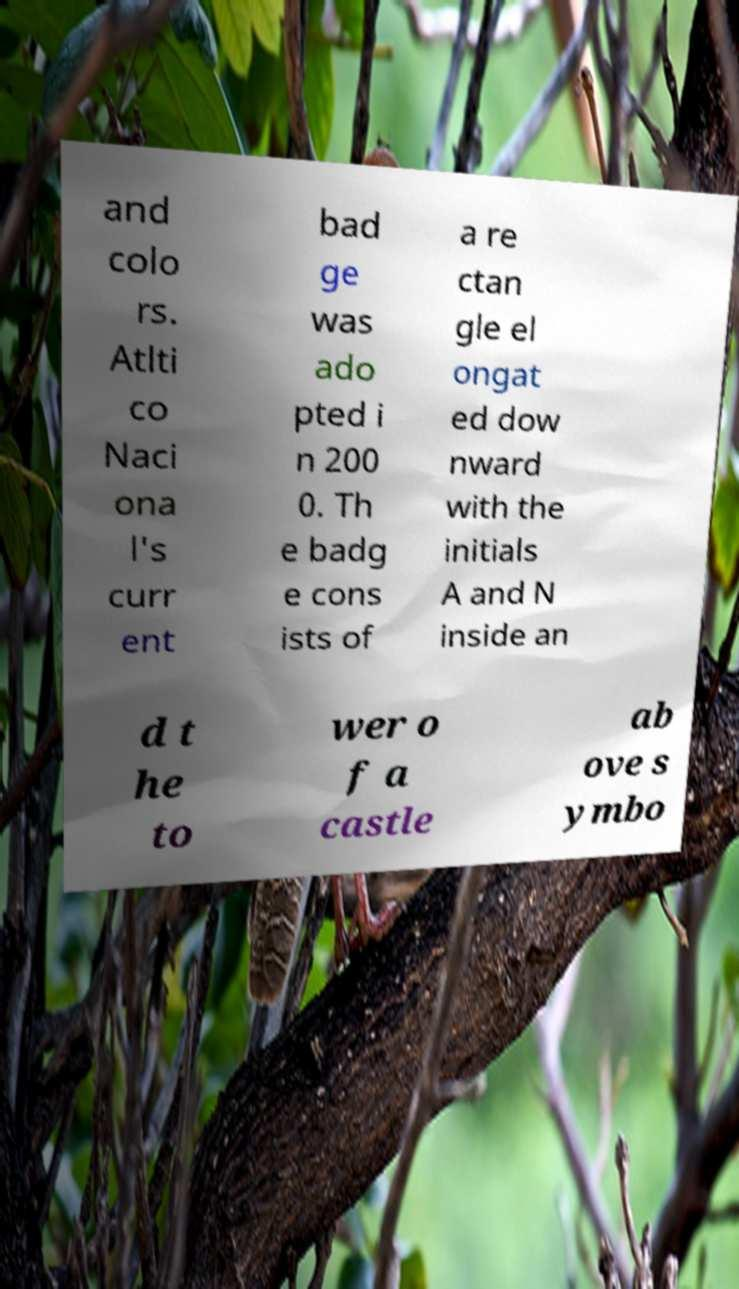I need the written content from this picture converted into text. Can you do that? and colo rs. Atlti co Naci ona l's curr ent bad ge was ado pted i n 200 0. Th e badg e cons ists of a re ctan gle el ongat ed dow nward with the initials A and N inside an d t he to wer o f a castle ab ove s ymbo 